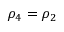Convert formula to latex. <formula><loc_0><loc_0><loc_500><loc_500>\rho _ { 4 } = \rho _ { 2 }</formula> 